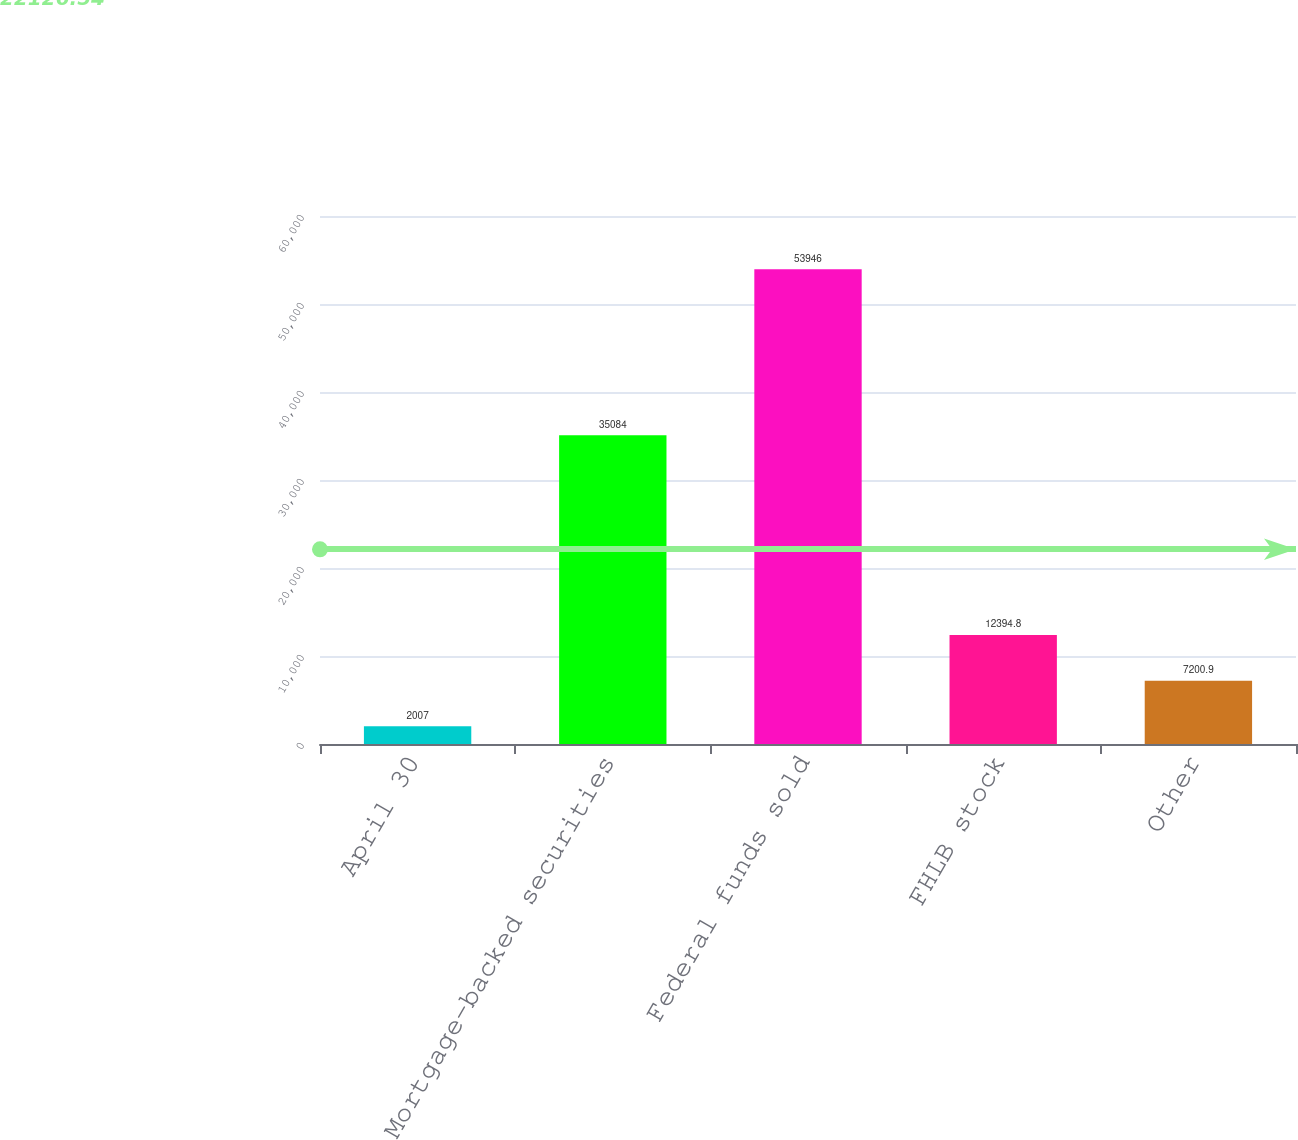<chart> <loc_0><loc_0><loc_500><loc_500><bar_chart><fcel>April 30<fcel>Mortgage-backed securities<fcel>Federal funds sold<fcel>FHLB stock<fcel>Other<nl><fcel>2007<fcel>35084<fcel>53946<fcel>12394.8<fcel>7200.9<nl></chart> 